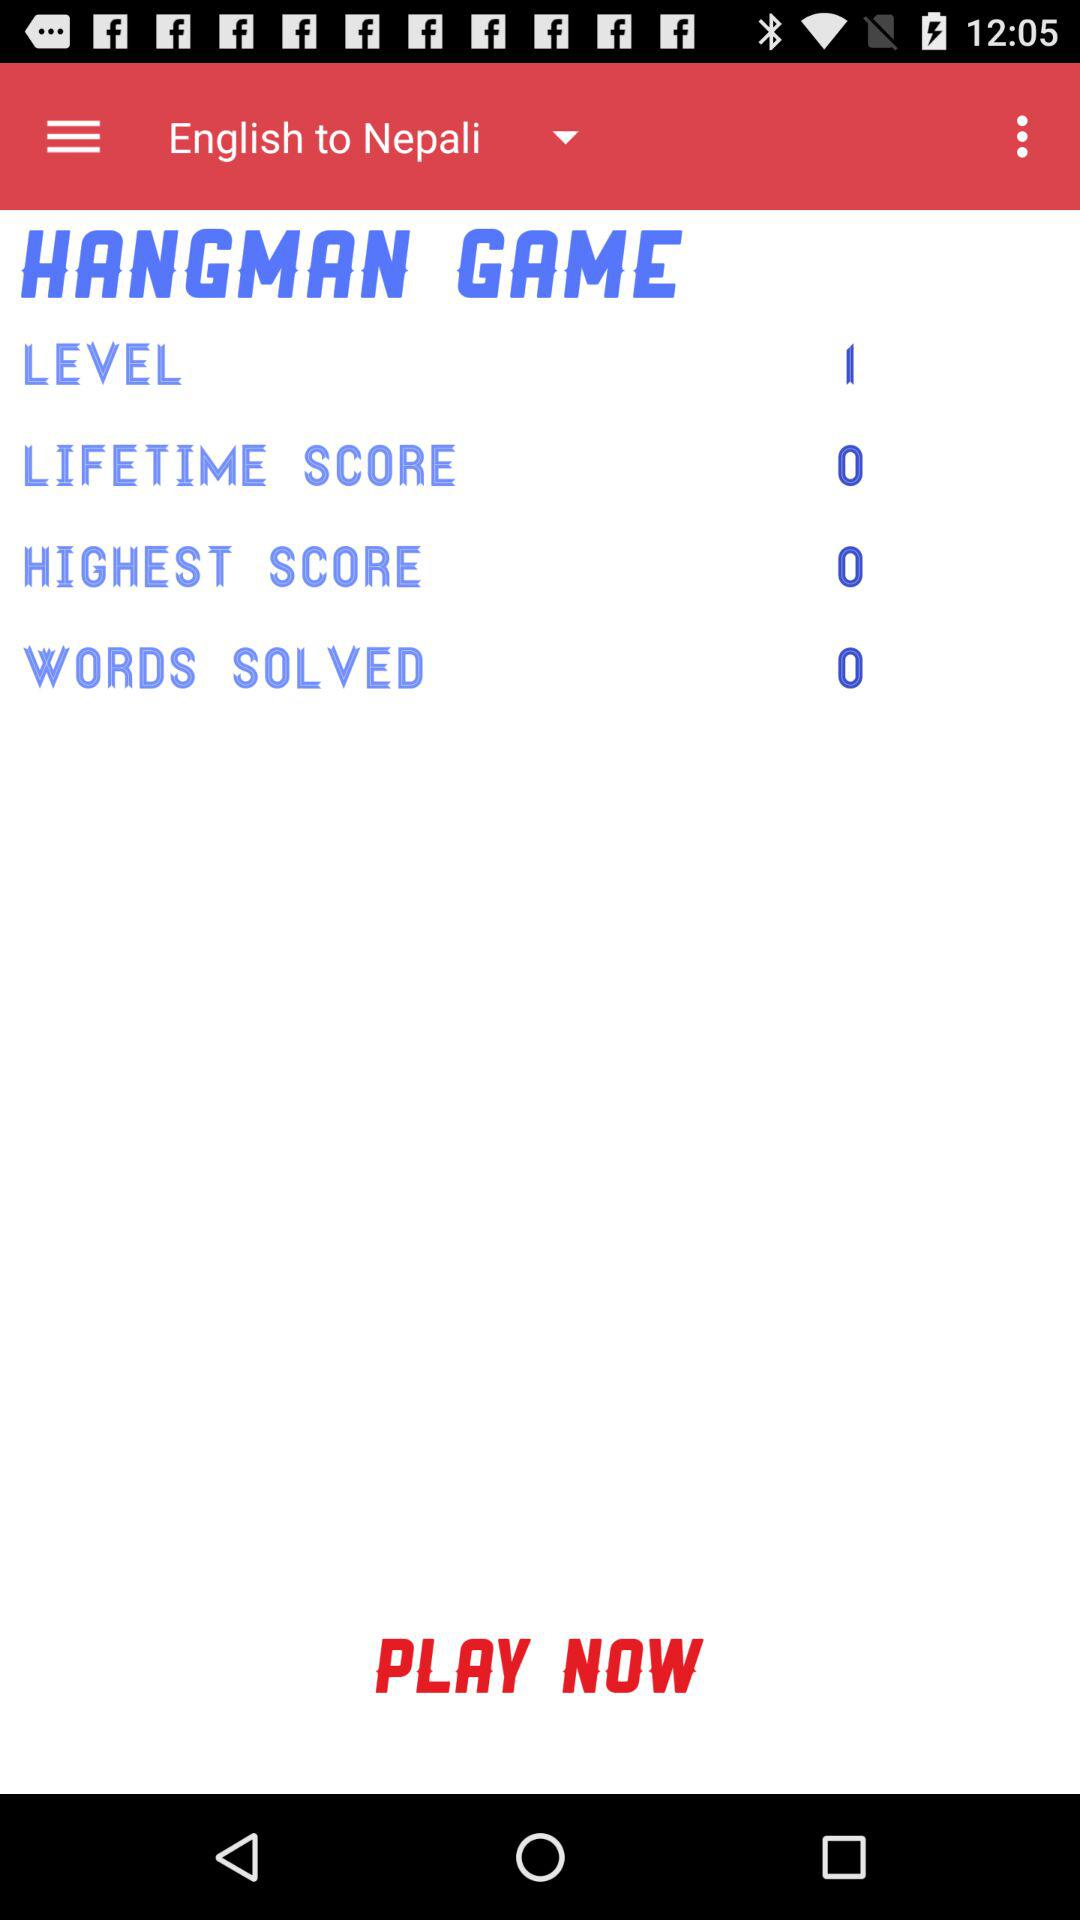What is the selected option for translation? The selected option for translation is "English to Nepali". 